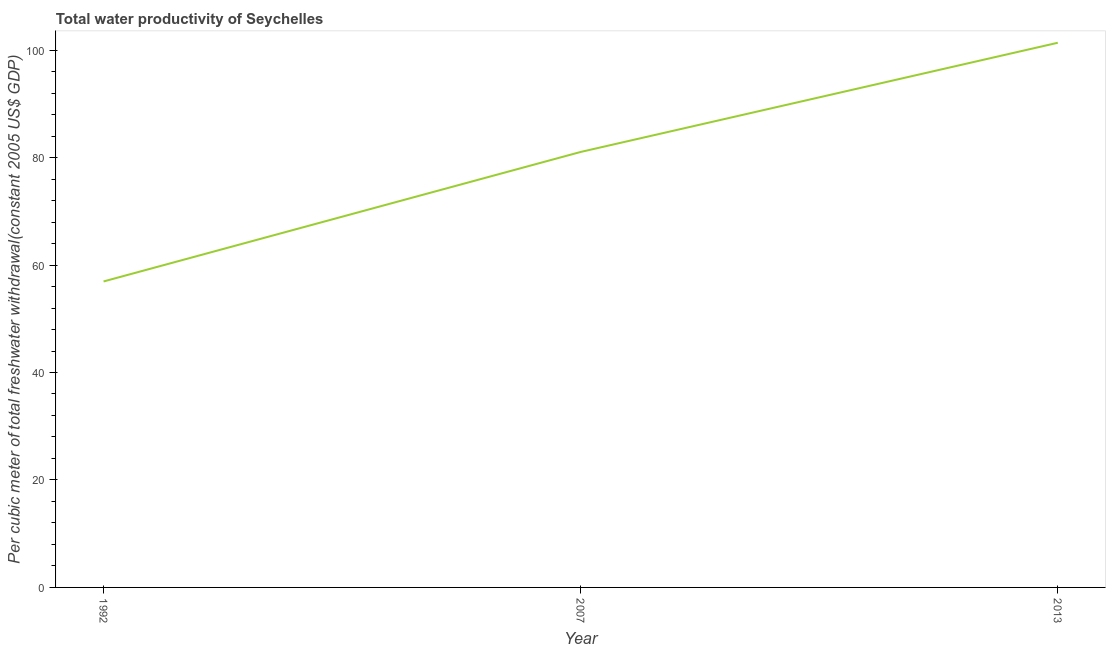What is the total water productivity in 2007?
Provide a short and direct response. 81.04. Across all years, what is the maximum total water productivity?
Keep it short and to the point. 101.37. Across all years, what is the minimum total water productivity?
Your answer should be compact. 56.94. In which year was the total water productivity minimum?
Your answer should be compact. 1992. What is the sum of the total water productivity?
Provide a succinct answer. 239.35. What is the difference between the total water productivity in 2007 and 2013?
Offer a terse response. -20.32. What is the average total water productivity per year?
Offer a very short reply. 79.78. What is the median total water productivity?
Offer a very short reply. 81.04. Do a majority of the years between 2007 and 1992 (inclusive) have total water productivity greater than 12 US$?
Your answer should be very brief. No. What is the ratio of the total water productivity in 1992 to that in 2013?
Keep it short and to the point. 0.56. Is the total water productivity in 1992 less than that in 2013?
Your answer should be compact. Yes. What is the difference between the highest and the second highest total water productivity?
Keep it short and to the point. 20.32. What is the difference between the highest and the lowest total water productivity?
Ensure brevity in your answer.  44.42. How many years are there in the graph?
Offer a very short reply. 3. Does the graph contain any zero values?
Your answer should be compact. No. Does the graph contain grids?
Keep it short and to the point. No. What is the title of the graph?
Make the answer very short. Total water productivity of Seychelles. What is the label or title of the X-axis?
Keep it short and to the point. Year. What is the label or title of the Y-axis?
Keep it short and to the point. Per cubic meter of total freshwater withdrawal(constant 2005 US$ GDP). What is the Per cubic meter of total freshwater withdrawal(constant 2005 US$ GDP) in 1992?
Give a very brief answer. 56.94. What is the Per cubic meter of total freshwater withdrawal(constant 2005 US$ GDP) in 2007?
Make the answer very short. 81.04. What is the Per cubic meter of total freshwater withdrawal(constant 2005 US$ GDP) of 2013?
Keep it short and to the point. 101.37. What is the difference between the Per cubic meter of total freshwater withdrawal(constant 2005 US$ GDP) in 1992 and 2007?
Make the answer very short. -24.1. What is the difference between the Per cubic meter of total freshwater withdrawal(constant 2005 US$ GDP) in 1992 and 2013?
Your response must be concise. -44.42. What is the difference between the Per cubic meter of total freshwater withdrawal(constant 2005 US$ GDP) in 2007 and 2013?
Offer a very short reply. -20.32. What is the ratio of the Per cubic meter of total freshwater withdrawal(constant 2005 US$ GDP) in 1992 to that in 2007?
Your answer should be very brief. 0.7. What is the ratio of the Per cubic meter of total freshwater withdrawal(constant 2005 US$ GDP) in 1992 to that in 2013?
Your answer should be very brief. 0.56. 